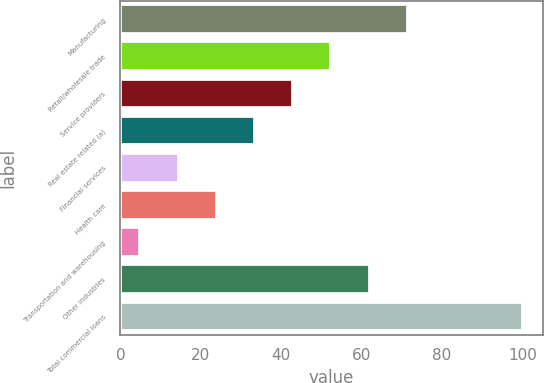<chart> <loc_0><loc_0><loc_500><loc_500><bar_chart><fcel>Manufacturing<fcel>Retail/wholesale trade<fcel>Service providers<fcel>Real estate related (a)<fcel>Financial services<fcel>Health care<fcel>Transportation and warehousing<fcel>Other industries<fcel>Total commercial loans<nl><fcel>71.5<fcel>52.5<fcel>43<fcel>33.5<fcel>14.5<fcel>24<fcel>5<fcel>62<fcel>100<nl></chart> 